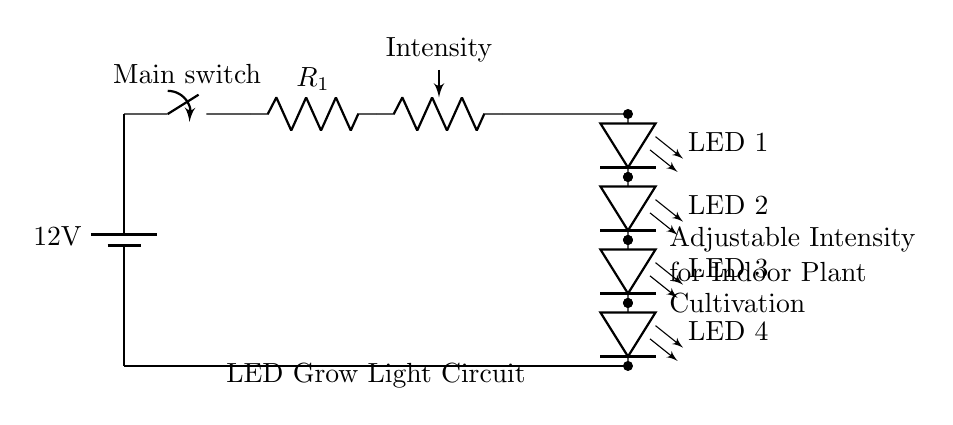What is the main voltage of this circuit? The main voltage is the value provided next to the battery symbol, indicating the power supply. In this case, it is twelve volts.
Answer: twelve volts What component is used to control the light intensity? The component used to control the light intensity is a potentiometer, indicated in the circuit as "Intensity." It allows varying the resistance, thus adjusting the current flowing to the LEDs.
Answer: potentiometer How many LED lights are there in the array? The circuit shows four individual LEDs lined up in an array, distinctively labeled as LED 1 through LED 4.
Answer: four What type of switch is used in this circuit? The switch is a main switch, labeled explicitly next to the switch symbol in the circuit. It is used to turn the entire circuit on or off.
Answer: main switch What is the purpose of the resistor labeled R1? The resistor labeled R1 serves to limit the current flowing through the circuit to prevent damage to the LEDs and ensure safe operation. Current limiting is crucial for LED functionality.
Answer: limit current 